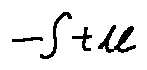Convert formula to latex. <formula><loc_0><loc_0><loc_500><loc_500>- \int t d l</formula> 